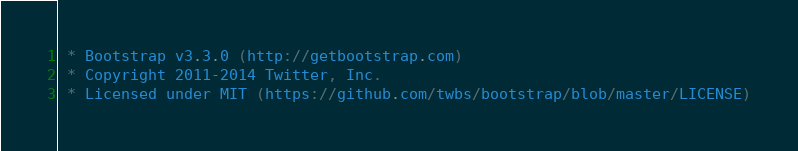<code> <loc_0><loc_0><loc_500><loc_500><_CSS_> * Bootstrap v3.3.0 (http://getbootstrap.com)
 * Copyright 2011-2014 Twitter, Inc.
 * Licensed under MIT (https://github.com/twbs/bootstrap/blob/master/LICENSE)</code> 